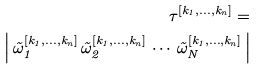Convert formula to latex. <formula><loc_0><loc_0><loc_500><loc_500>\tau ^ { [ k _ { 1 } , \dots , k _ { n } ] } = \\ \left | \, \vec { \omega } _ { 1 } ^ { [ k _ { 1 } , \dots , k _ { n } ] } \, \vec { \omega } _ { 2 } ^ { [ k _ { 1 } , \dots , k _ { n } ] } \, \cdots \, \vec { \omega } _ { N } ^ { [ k _ { 1 } , \dots , k _ { n } ] } \, \right |</formula> 